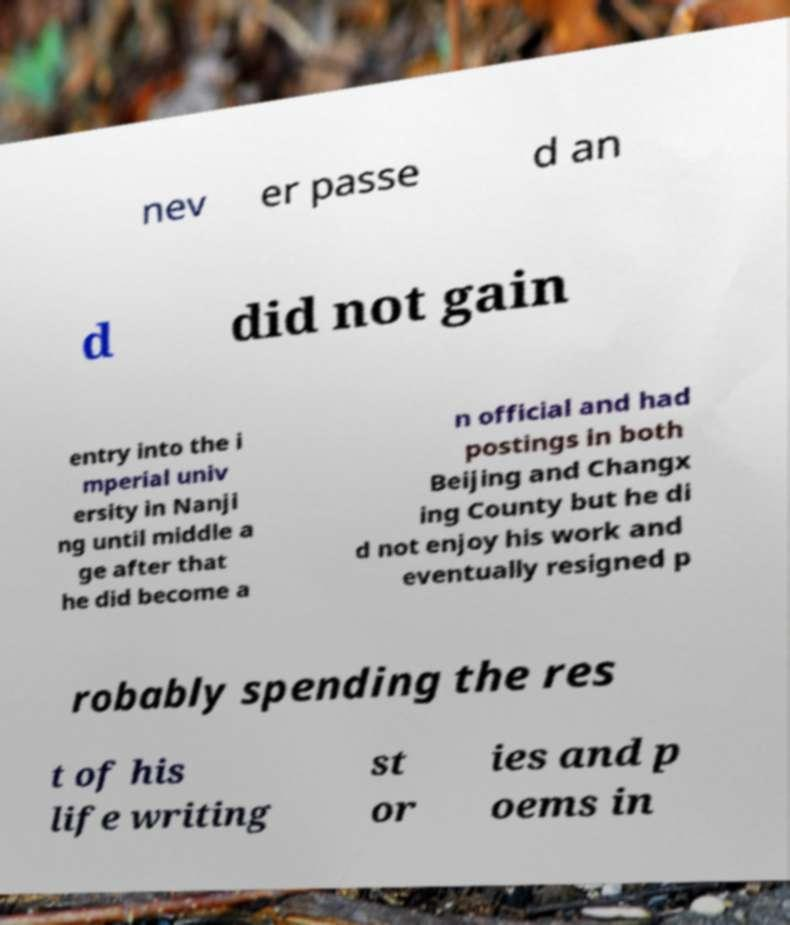Could you assist in decoding the text presented in this image and type it out clearly? nev er passe d an d did not gain entry into the i mperial univ ersity in Nanji ng until middle a ge after that he did become a n official and had postings in both Beijing and Changx ing County but he di d not enjoy his work and eventually resigned p robably spending the res t of his life writing st or ies and p oems in 